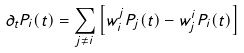Convert formula to latex. <formula><loc_0><loc_0><loc_500><loc_500>\partial _ { t } P _ { i } ( t ) = \sum _ { j \neq i } \left [ w _ { i } ^ { j } P _ { j } ( t ) - w _ { j } ^ { i } P _ { i } ( t ) \right ]</formula> 